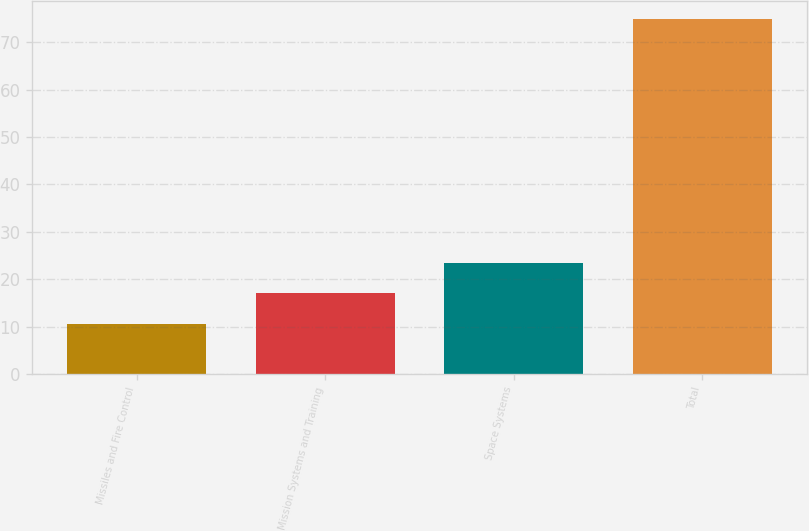Convert chart to OTSL. <chart><loc_0><loc_0><loc_500><loc_500><bar_chart><fcel>Missiles and Fire Control<fcel>Mission Systems and Training<fcel>Space Systems<fcel>Total<nl><fcel>10.6<fcel>17.03<fcel>23.46<fcel>74.9<nl></chart> 